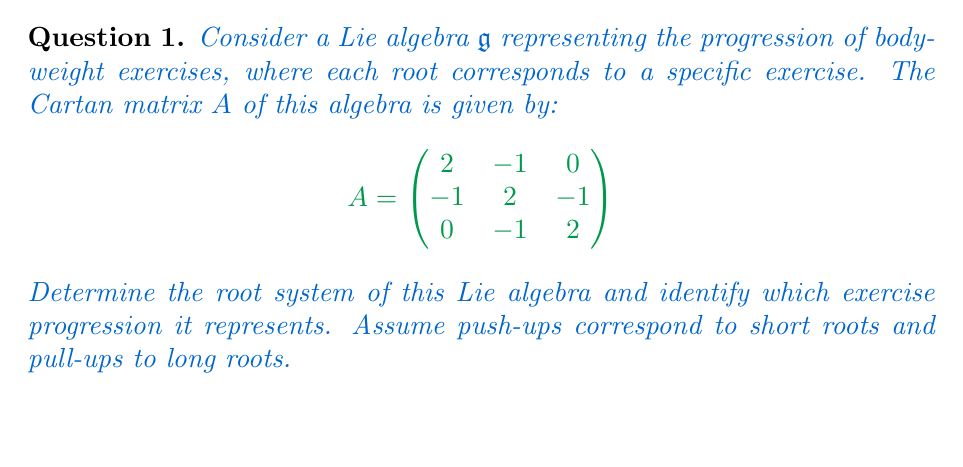Help me with this question. Let's approach this step-by-step:

1) The Cartan matrix $A$ corresponds to a rank-3 Lie algebra. From its structure, we can identify this as the $A_3$ Lie algebra, also known as $\mathfrak{sl}(4)$.

2) The root system of $A_3$ consists of 12 roots:
   - 6 positive roots: $\alpha_1$, $\alpha_2$, $\alpha_3$, $\alpha_1+\alpha_2$, $\alpha_2+\alpha_3$, $\alpha_1+\alpha_2+\alpha_3$
   - 6 negative roots: $-\alpha_1$, $-\alpha_2$, $-\alpha_3$, $-(\alpha_1+\alpha_2)$, $-(\alpha_2+\alpha_3)$, $-(\alpha_1+\alpha_2+\alpha_3)$

3) In the $A_3$ root system, all roots have the same length. This means our exercise progression involves only one type of exercise.

4) Given that push-ups correspond to short roots and pull-ups to long roots, and all roots here have the same length, we can conclude that this system represents a push-up progression.

5) The three simple roots $\alpha_1$, $\alpha_2$, and $\alpha_3$ could represent three basic push-up variations, such as:
   $\alpha_1$: Standard push-ups
   $\alpha_2$: Diamond push-ups
   $\alpha_3$: Wide push-ups

6) The compound roots then represent combinations or progressions of these exercises:
   $\alpha_1+\alpha_2$: Standard to diamond push-up transition
   $\alpha_2+\alpha_3$: Diamond to wide push-up transition
   $\alpha_1+\alpha_2+\alpha_3$: Full push-up variation cycle

7) The negative roots could represent the eccentric (lowering) phase of each exercise.

This root system thus describes a comprehensive push-up progression system, incorporating various forms and transitions between them.
Answer: $A_3$ root system representing push-up progression 